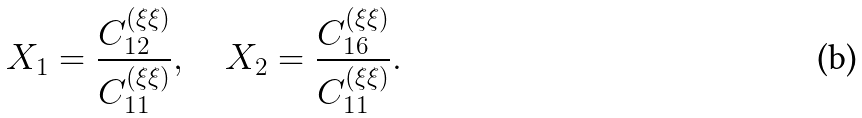<formula> <loc_0><loc_0><loc_500><loc_500>X _ { 1 } = \frac { C _ { 1 2 } ^ { ( \xi \xi ) } } { C _ { 1 1 } ^ { ( \xi \xi ) } } , \quad X _ { 2 } = \frac { C _ { 1 6 } ^ { ( \xi \xi ) } } { C _ { 1 1 } ^ { ( \xi \xi ) } } .</formula> 